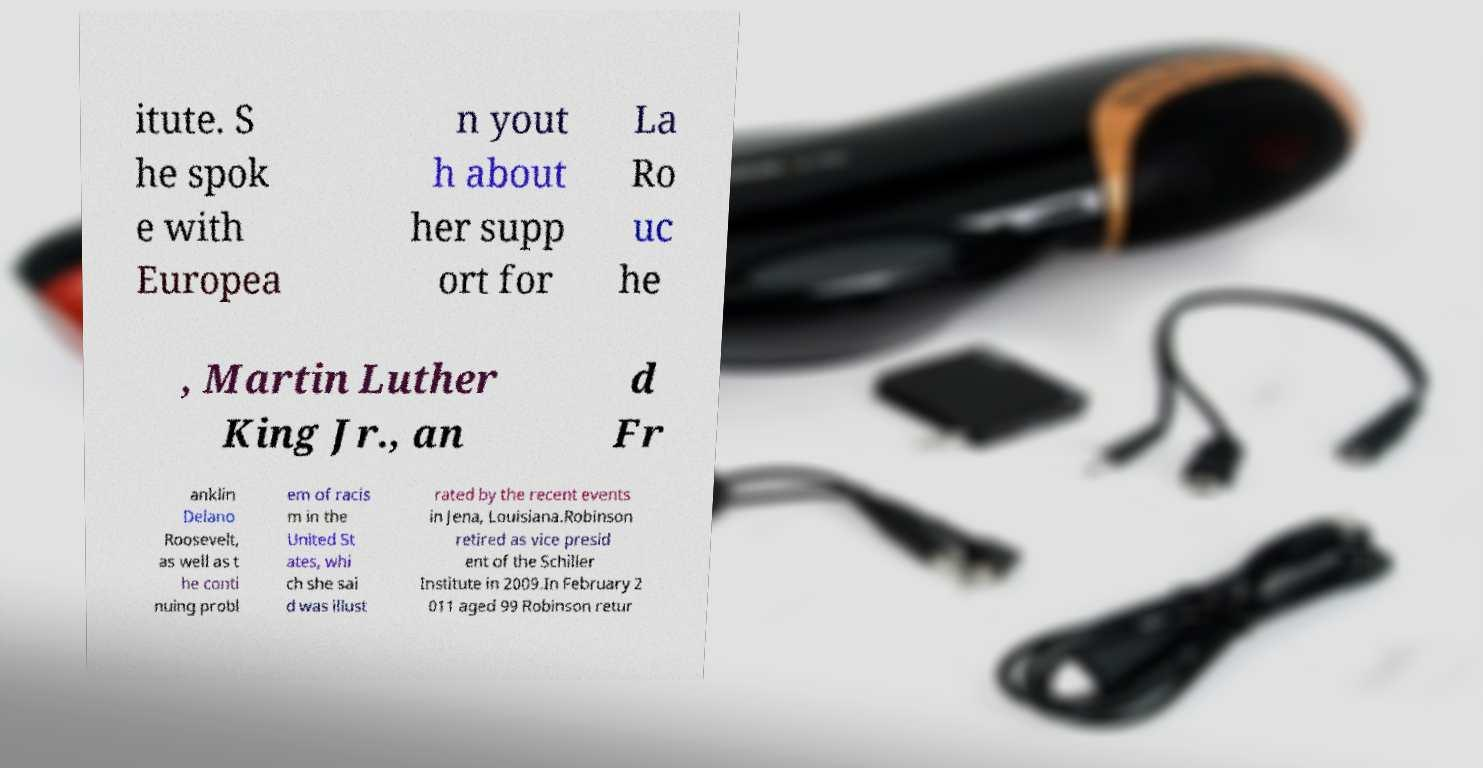There's text embedded in this image that I need extracted. Can you transcribe it verbatim? itute. S he spok e with Europea n yout h about her supp ort for La Ro uc he , Martin Luther King Jr., an d Fr anklin Delano Roosevelt, as well as t he conti nuing probl em of racis m in the United St ates, whi ch she sai d was illust rated by the recent events in Jena, Louisiana.Robinson retired as vice presid ent of the Schiller Institute in 2009.In February 2 011 aged 99 Robinson retur 